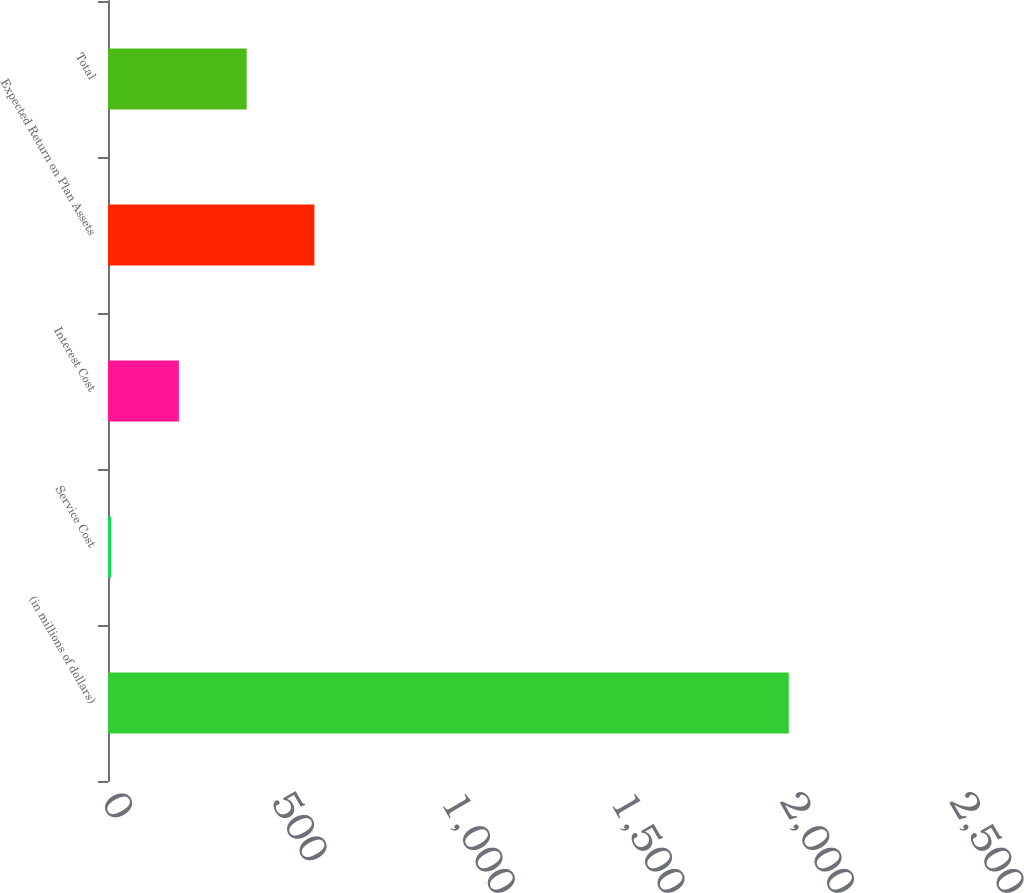Convert chart to OTSL. <chart><loc_0><loc_0><loc_500><loc_500><bar_chart><fcel>(in millions of dollars)<fcel>Service Cost<fcel>Interest Cost<fcel>Expected Return on Plan Assets<fcel>Total<nl><fcel>2007<fcel>9.2<fcel>208.98<fcel>608.54<fcel>408.76<nl></chart> 